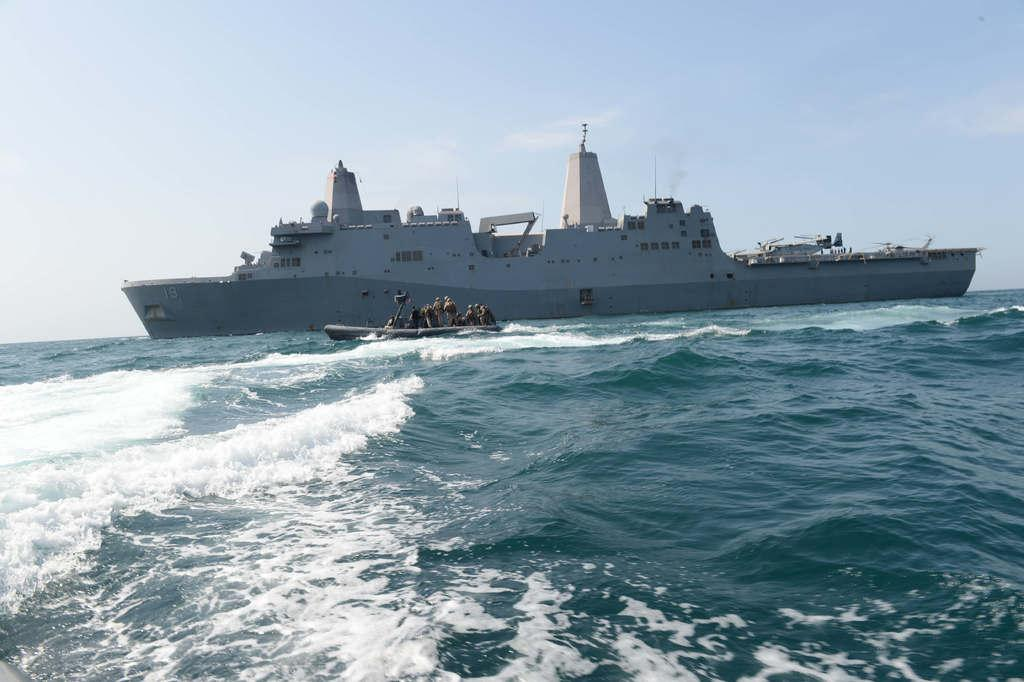What is the main subject of the image? The main subject of the image is a ship. Where is the ship located? The ship is in the ocean. What other watercraft is visible in the image? There is a boat in the image. How close is the boat to the ship? The boat is near the ship. Are there any people on the boat? Yes, there are people on the boat. What can be seen at the top of the image? The sky is visible at the top of the image. What type of jelly can be seen floating in the ocean near the ship? There is no jelly visible in the image; it is a ship and a boat in the ocean. 